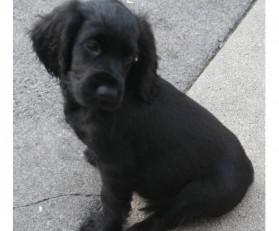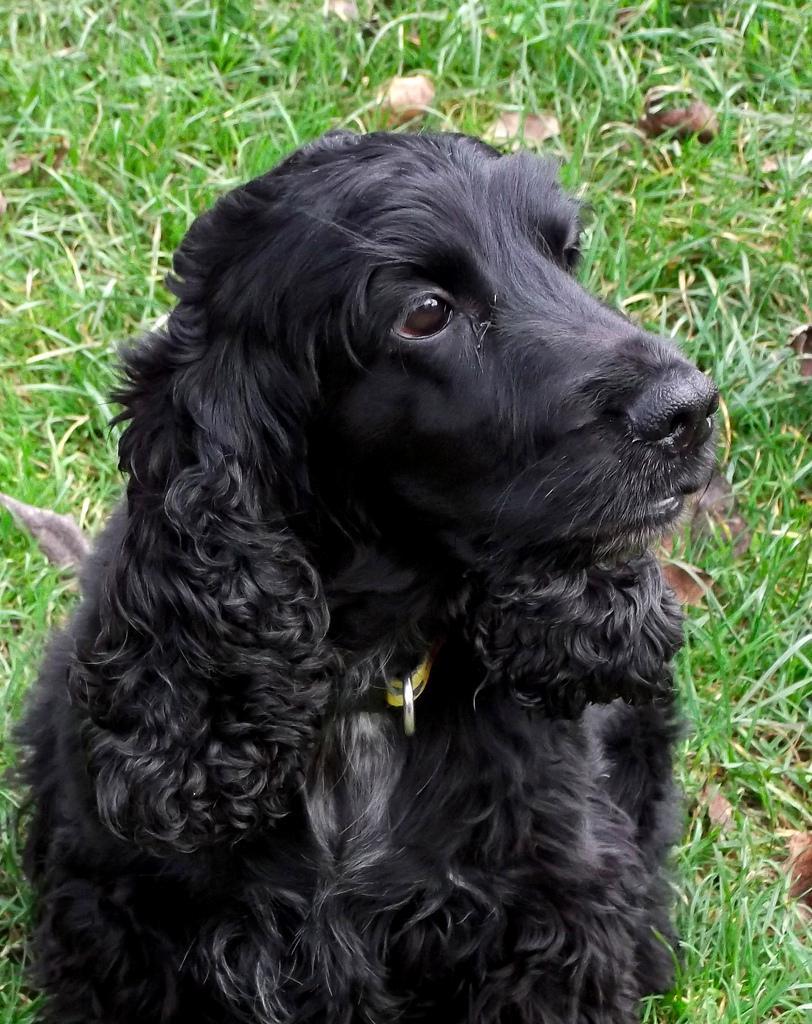The first image is the image on the left, the second image is the image on the right. Considering the images on both sides, is "An image shows a black-faced dog posed on green grass, touching some type of toy in front of it." valid? Answer yes or no. No. 